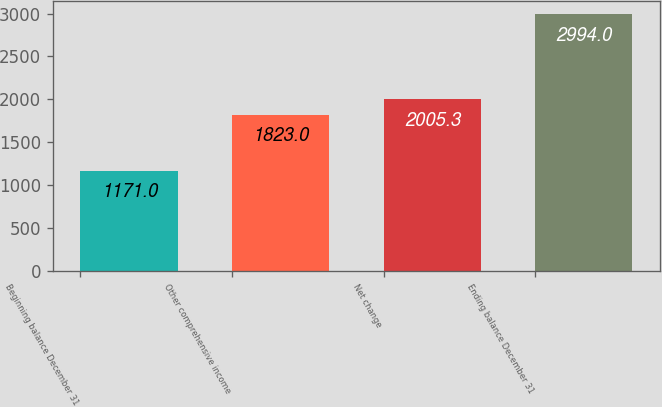Convert chart to OTSL. <chart><loc_0><loc_0><loc_500><loc_500><bar_chart><fcel>Beginning balance December 31<fcel>Other comprehensive income<fcel>Net change<fcel>Ending balance December 31<nl><fcel>1171<fcel>1823<fcel>2005.3<fcel>2994<nl></chart> 